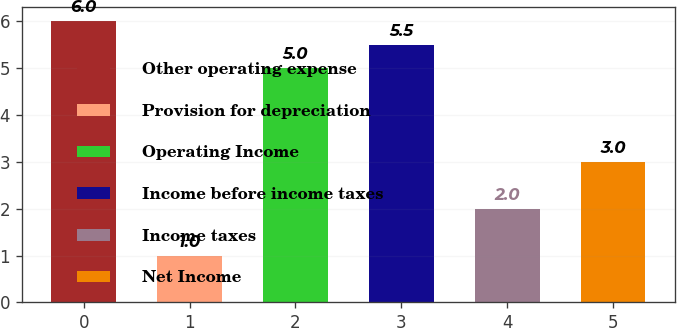<chart> <loc_0><loc_0><loc_500><loc_500><bar_chart><fcel>Other operating expense<fcel>Provision for depreciation<fcel>Operating Income<fcel>Income before income taxes<fcel>Income taxes<fcel>Net Income<nl><fcel>6<fcel>1<fcel>5<fcel>5.5<fcel>2<fcel>3<nl></chart> 